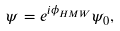Convert formula to latex. <formula><loc_0><loc_0><loc_500><loc_500>\psi = e ^ { i \phi _ { H M W } } \psi _ { 0 } ,</formula> 